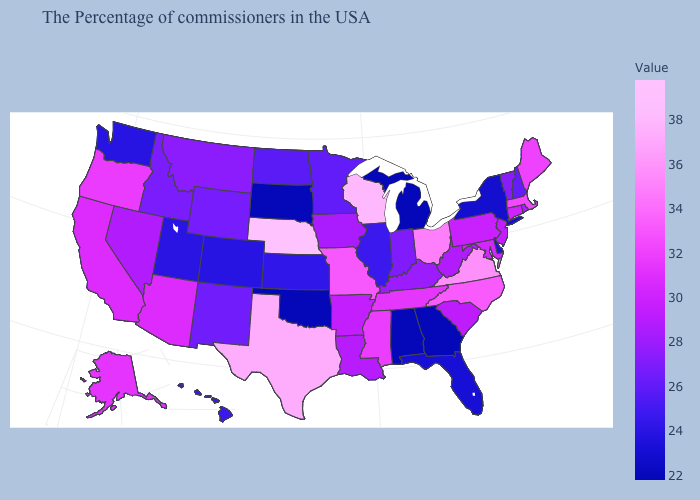Which states hav the highest value in the West?
Write a very short answer. Oregon. Is the legend a continuous bar?
Answer briefly. Yes. Does Indiana have the lowest value in the MidWest?
Answer briefly. No. Which states have the highest value in the USA?
Keep it brief. Nebraska. Does New Hampshire have the lowest value in the Northeast?
Quick response, please. No. 